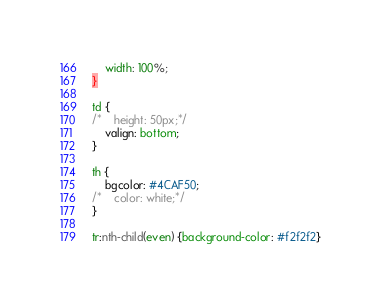<code> <loc_0><loc_0><loc_500><loc_500><_CSS_>    width: 100%;
}

td {
/*    height: 50px;*/
    valign: bottom;
}

th {
    bgcolor: #4CAF50;
/*    color: white;*/
}

tr:nth-child(even) {background-color: #f2f2f2}
</code> 